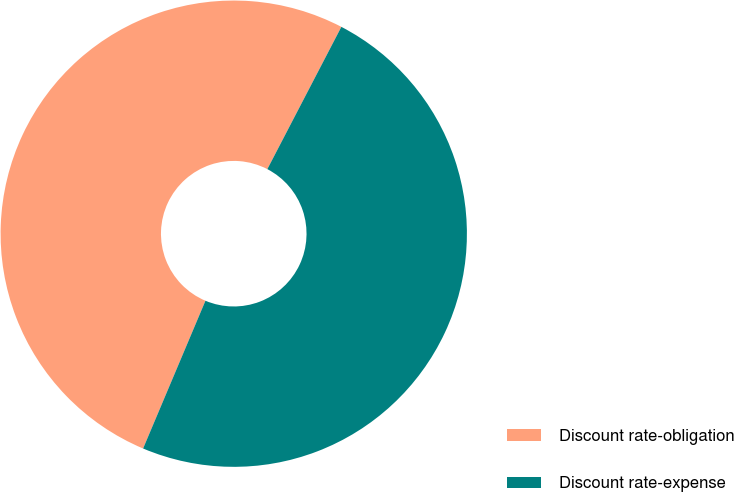Convert chart. <chart><loc_0><loc_0><loc_500><loc_500><pie_chart><fcel>Discount rate-obligation<fcel>Discount rate-expense<nl><fcel>51.28%<fcel>48.72%<nl></chart> 